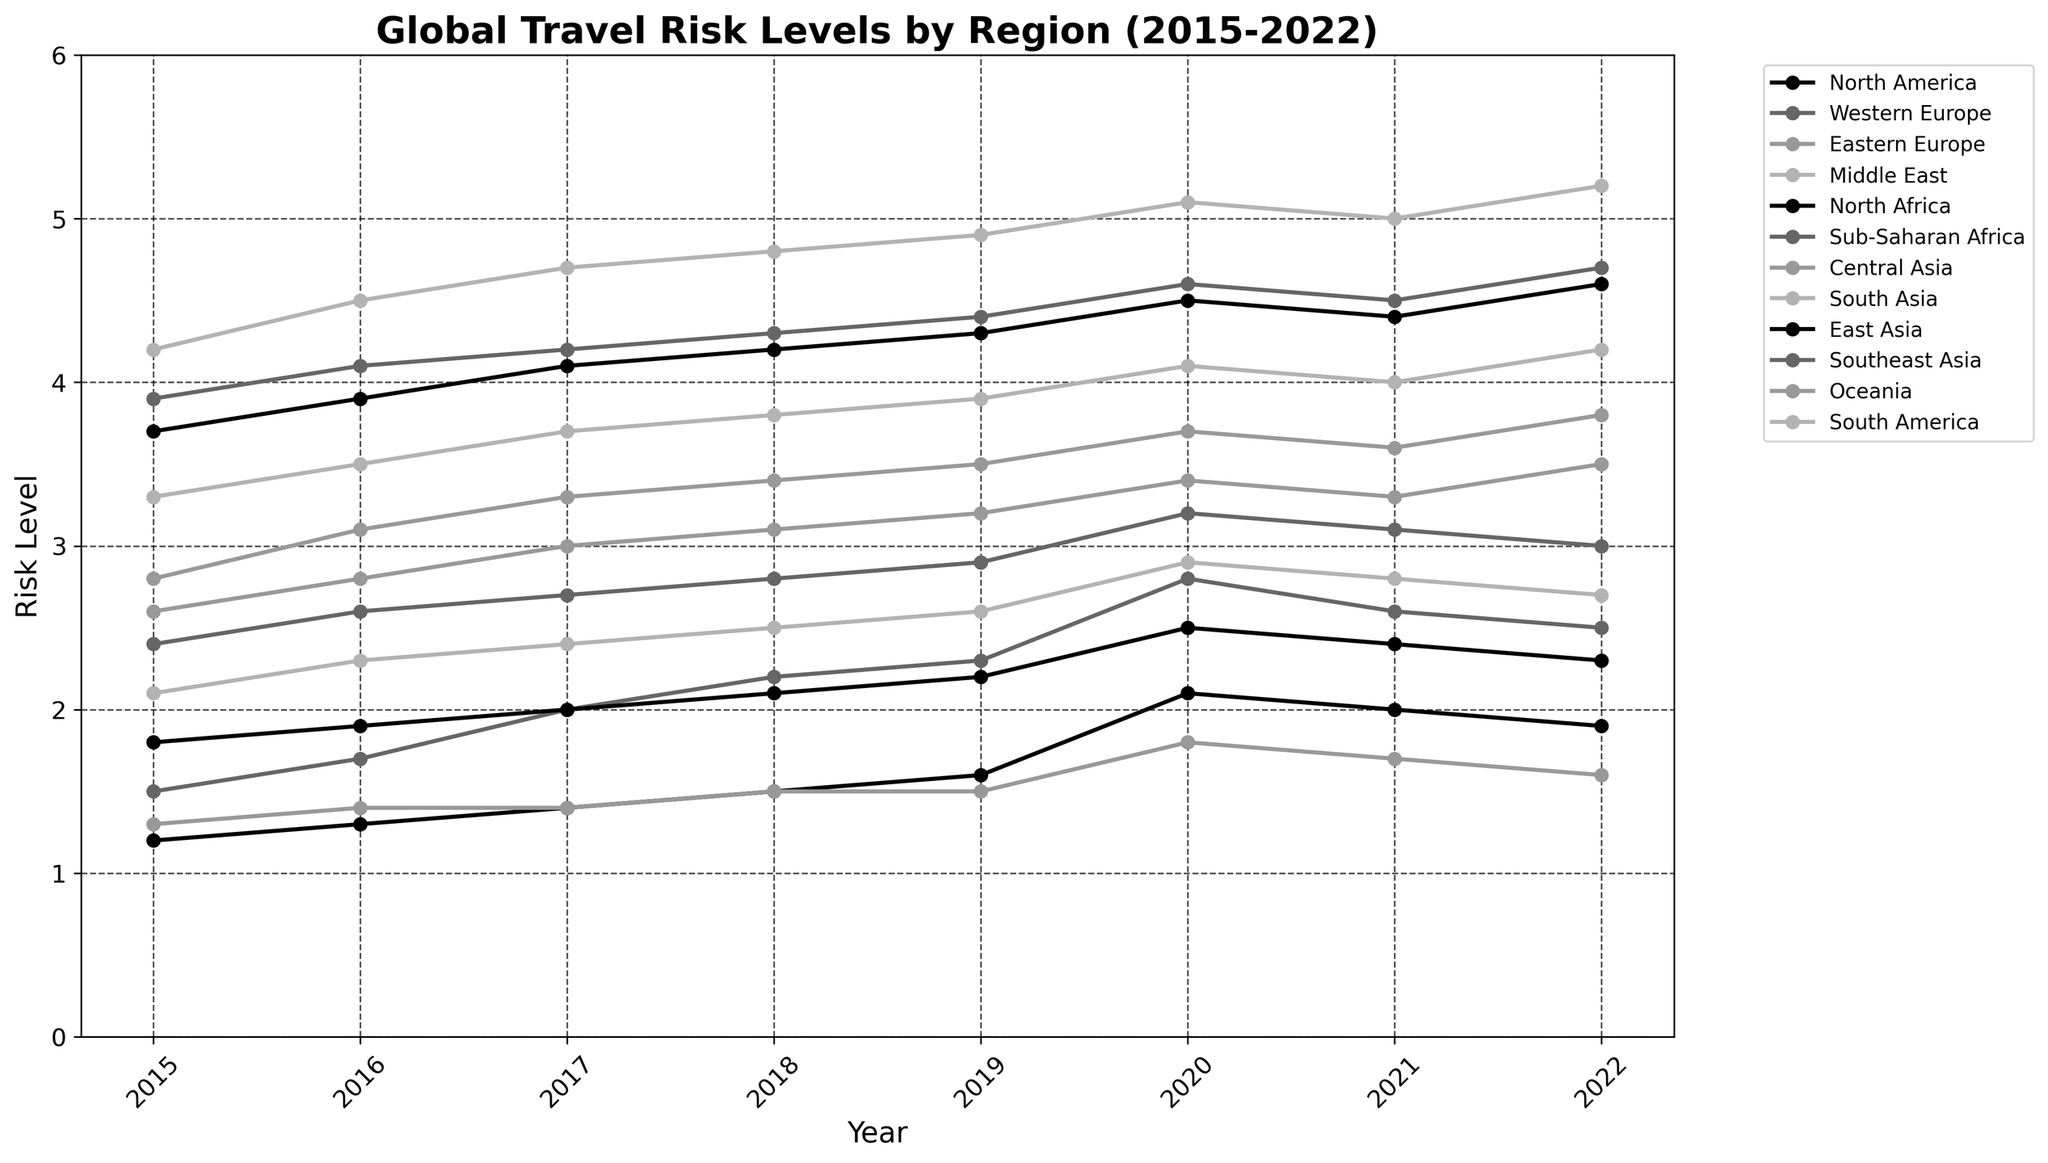Which region had the highest travel risk level in 2022? We look at each region's data point for the year 2022 and identify the one with the highest value. The Middle East shows a risk level of 5.2, which is the highest among all the regions for that year.
Answer: Middle East Between which consecutive years did North America's travel risk level increase the most? To find this, we look at the differences between consecutive years for North America. The biggest increase is between 2019 (1.6) and 2020 (2.1), a difference of 0.5.
Answer: 2019-2020 Which two regions had nearly identical travel risk levels in 2020? We compare the risk levels for all regions in 2020 and look for similar values. South America (2.9) and Southeast Asia (3.2) had close risk levels, but Western Europe (2.8) and Central Asia (3.4) had even closer values, each differing by only 0.6.
Answer: Western Europe and Central Asia What is the average travel risk level of Oceania from 2015 to 2022? To calculate the average, we sum the risk levels for Oceania from 2015 to 2022 and divide by the number of years. Sum is 1.3 + 1.4 + 1.4 + 1.5 + 1.5 + 1.8 + 1.7 + 1.6 = 12.2. Dividing by 8 years gives us 12.2 / 8 = 1.53
Answer: 1.53 In which region did the travel risk level increase continuously from 2015 to 2019? We look at each region's data points from 2015 to 2019 and identify those with a continuous increase. Central Asia shows a steady increase from 2.6 in 2015 to 3.2 in 2019.
Answer: Central Asia Which region had the highest increase in travel risk from 2015 to 2022? We calculate the increase by subtracting the 2015 value from the 2022 value for each region. The Middle East increased from 4.2 to 5.2, a difference of 1.0, which is the highest among all regions.
Answer: Middle East What is the median travel risk level of South Asia over the given years? We arrange the yearly risk levels for South Asia in ascending order and find the median. The values are 3.3, 3.5, 3.7, 3.8, 3.9, 4.0, 4.1, 4.2. The median is the average of the 4th and 5th values: (3.8 + 3.9) / 2 = 3.85
Answer: 3.85 Which region had a higher travel risk level than Eastern Europe in 2017 but lower in 2019? Comparing respective values, North Africa had a travel risk level of 4.1 in 2017 and 4.3 in 2019; Eastern Europe was 3.3 in 2017 and 3.5 in 2019. Hence, North Africa had a higher risk level in 2017 but lower in 2019.
Answer: North Africa 